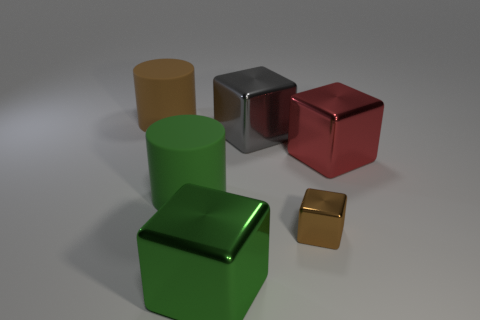Subtract all large metal cubes. How many cubes are left? 1 Subtract all brown cubes. How many cubes are left? 3 Subtract all purple blocks. Subtract all green balls. How many blocks are left? 4 Add 3 big green cylinders. How many objects exist? 9 Subtract all cubes. How many objects are left? 2 Add 6 metallic things. How many metallic things are left? 10 Add 4 small brown matte cylinders. How many small brown matte cylinders exist? 4 Subtract 1 green cubes. How many objects are left? 5 Subtract all big yellow cylinders. Subtract all big metallic things. How many objects are left? 3 